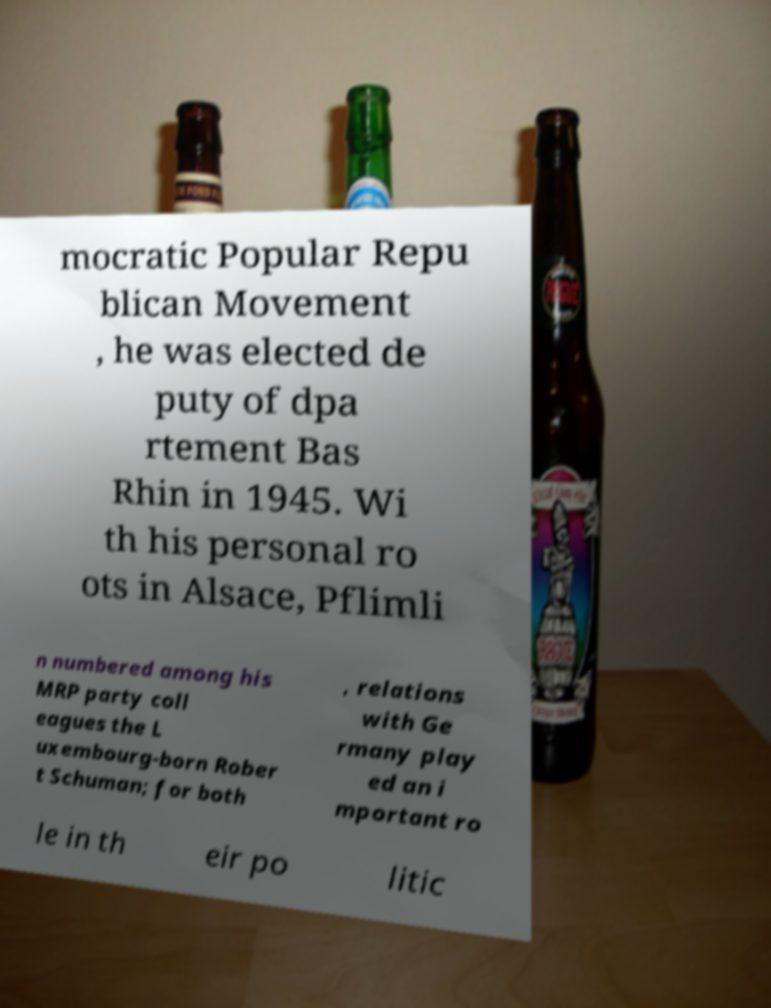Can you read and provide the text displayed in the image?This photo seems to have some interesting text. Can you extract and type it out for me? mocratic Popular Repu blican Movement , he was elected de puty of dpa rtement Bas Rhin in 1945. Wi th his personal ro ots in Alsace, Pflimli n numbered among his MRP party coll eagues the L uxembourg-born Rober t Schuman; for both , relations with Ge rmany play ed an i mportant ro le in th eir po litic 